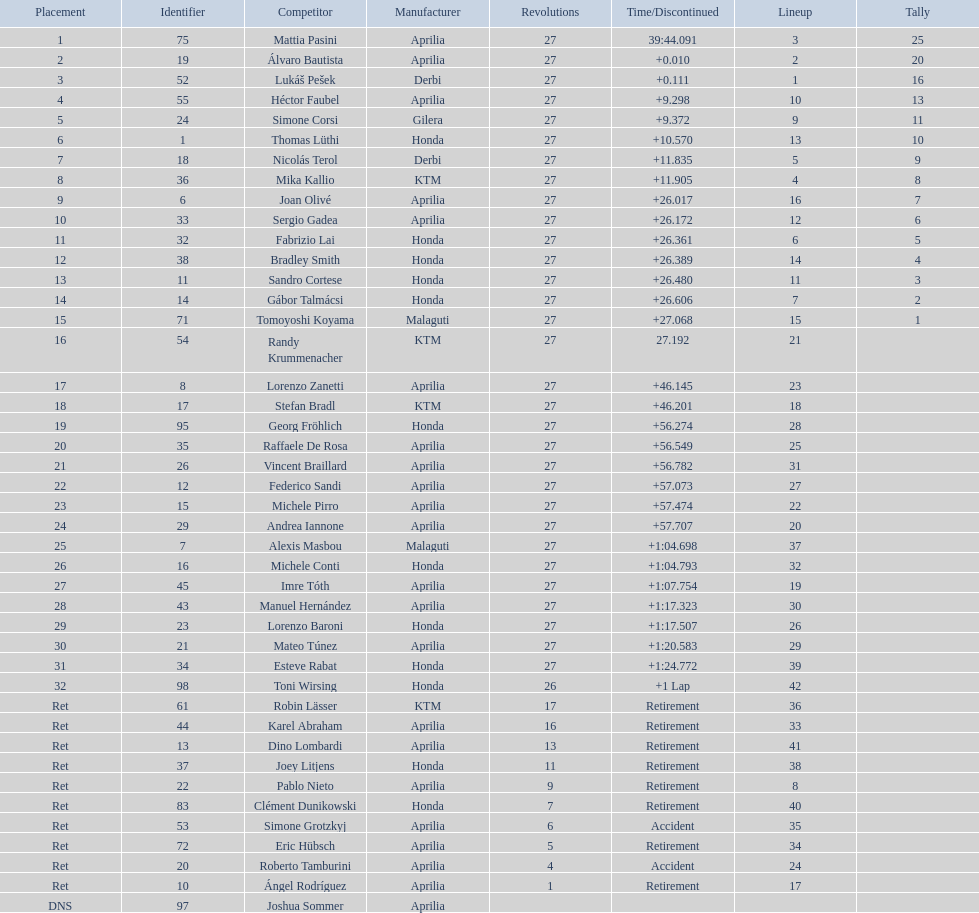Name a racer that had at least 20 points. Mattia Pasini. 